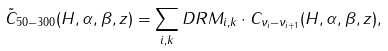Convert formula to latex. <formula><loc_0><loc_0><loc_500><loc_500>\tilde { C } _ { 5 0 - 3 0 0 } ( H , \alpha , \beta , z ) = \sum _ { i , k } D R M _ { i , k } \cdot C _ { \nu _ { i } - \nu _ { i + 1 } } ( H , \alpha , \beta , z ) ,</formula> 